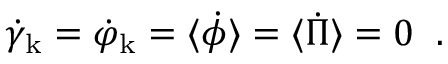<formula> <loc_0><loc_0><loc_500><loc_500>\dot { \gamma } _ { k } = \dot { \varphi } _ { k } = \langle \dot { \phi } \rangle = \langle \dot { \Pi } \rangle = 0 \, .</formula> 